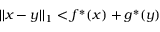<formula> <loc_0><loc_0><loc_500><loc_500>| | x - y | | _ { 1 } < f ^ { * } ( x ) + g ^ { * } ( y )</formula> 